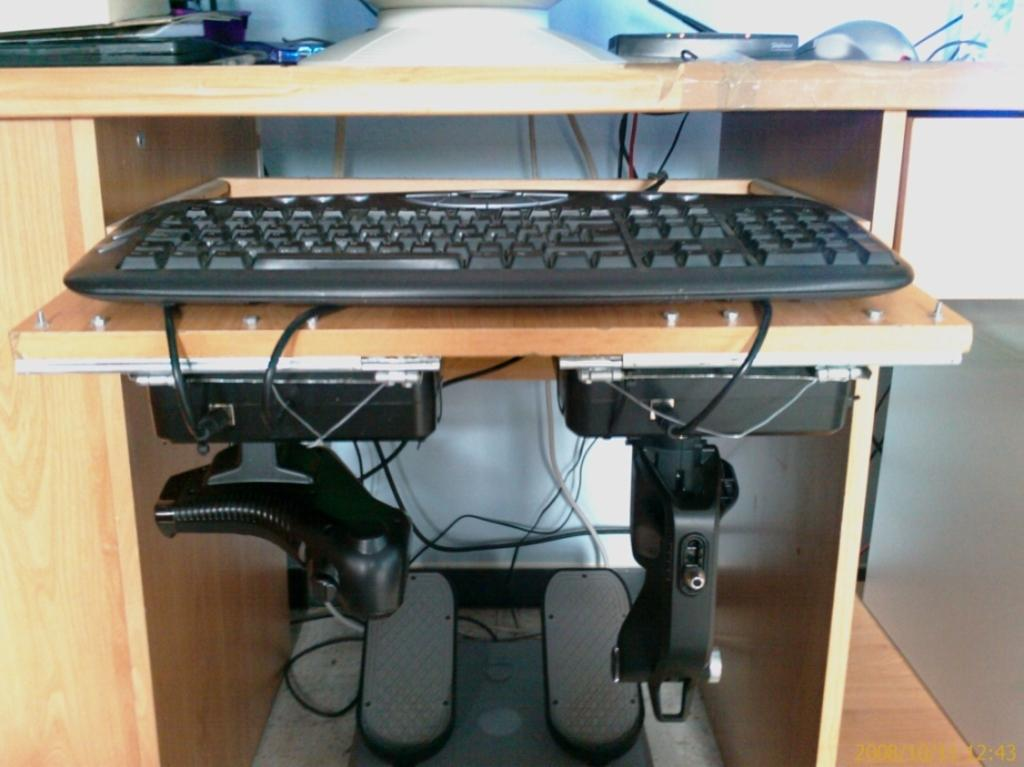What is on the table in the image? There is a keyboard on the table. Are there any connections to the keyboard? Yes, wires are attached to the keyboard. What can be seen behind the table? There is a wall in front of the table. What else is on the table besides the keyboard? There are other objects on the table. How does the grass increase in the image? There is no grass present in the image, so it cannot increase. 